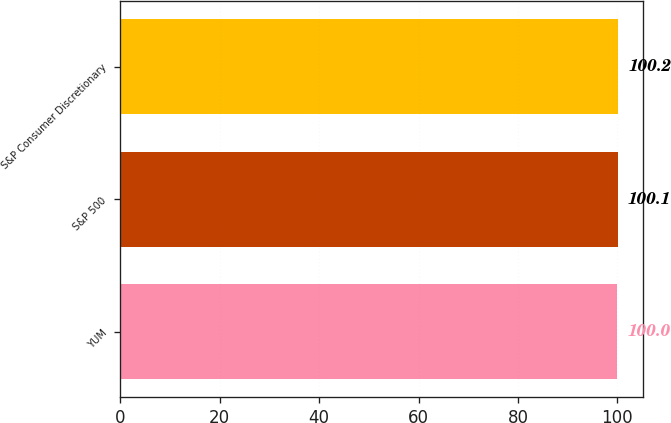Convert chart. <chart><loc_0><loc_0><loc_500><loc_500><bar_chart><fcel>YUM<fcel>S&P 500<fcel>S&P Consumer Discretionary<nl><fcel>100<fcel>100.1<fcel>100.2<nl></chart> 